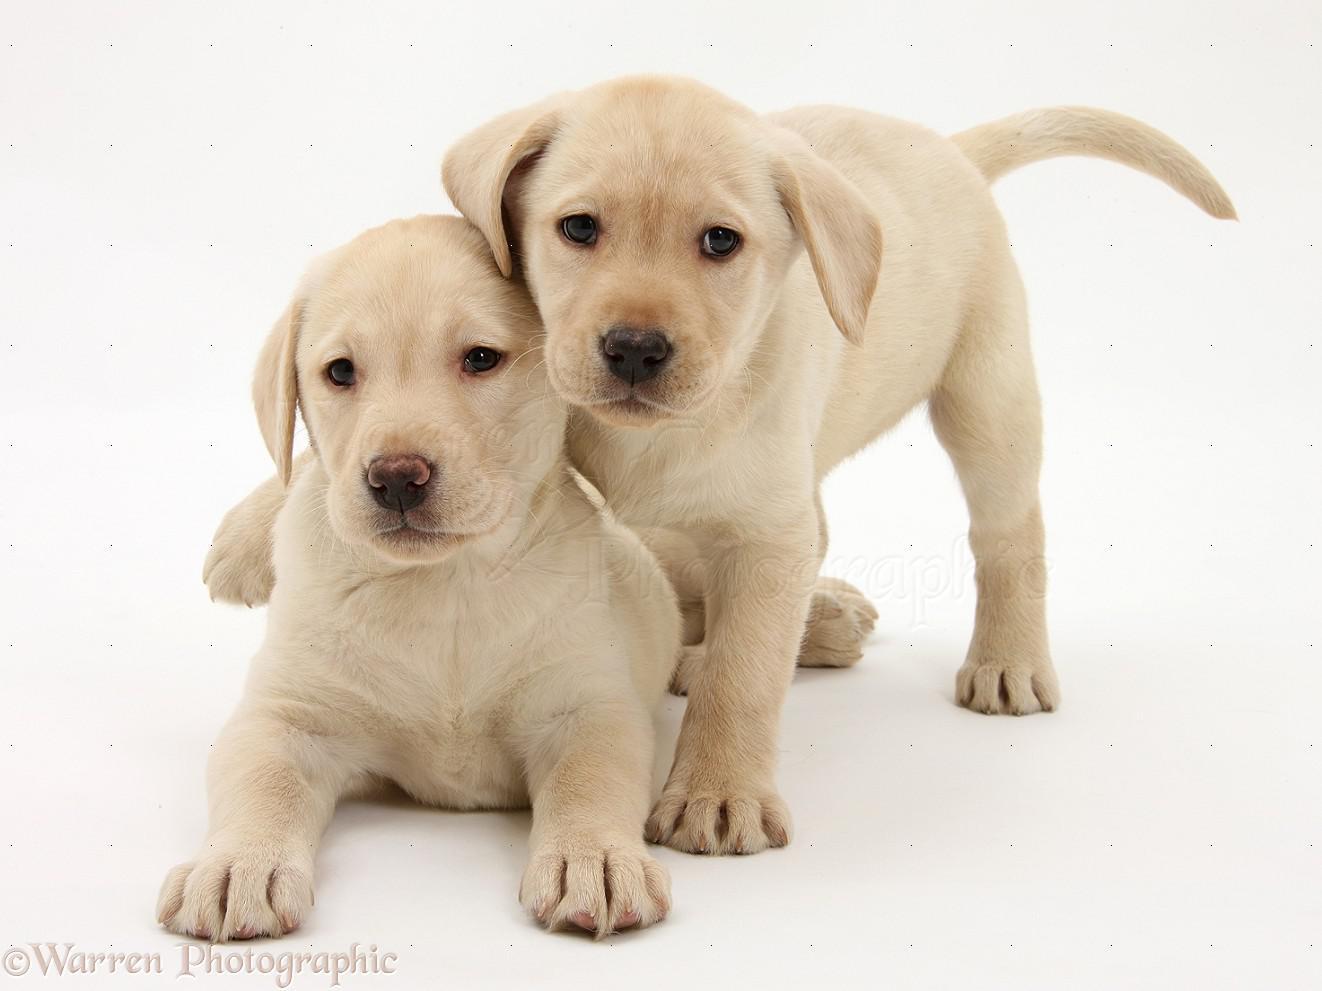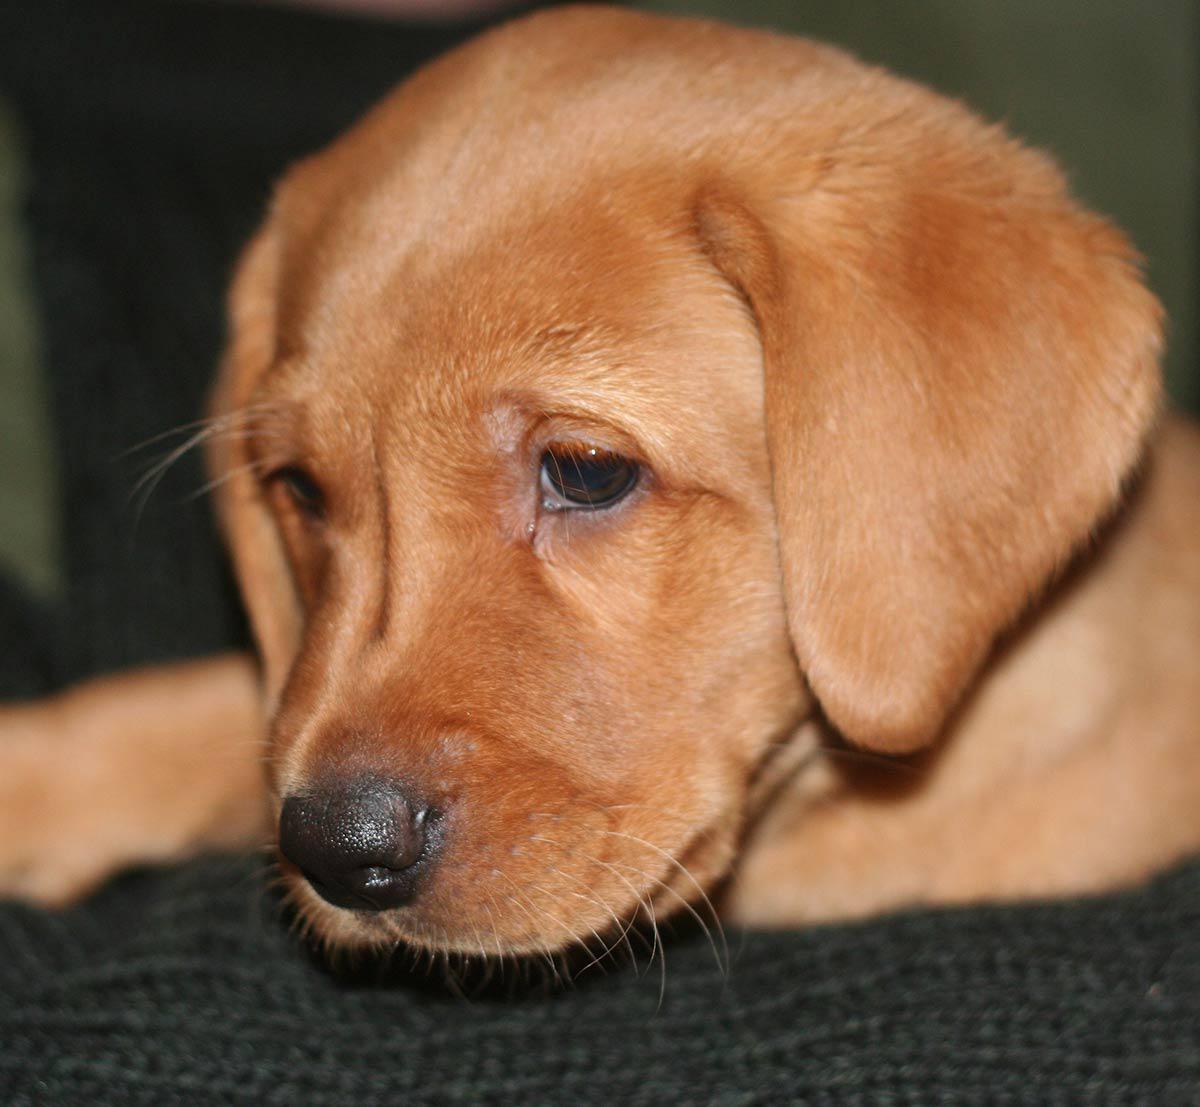The first image is the image on the left, the second image is the image on the right. Assess this claim about the two images: "All dogs are puppies with light-colored fur, and each image features a pair of puppies posed close together.". Correct or not? Answer yes or no. No. The first image is the image on the left, the second image is the image on the right. For the images displayed, is the sentence "There are 4 puppies." factually correct? Answer yes or no. No. 